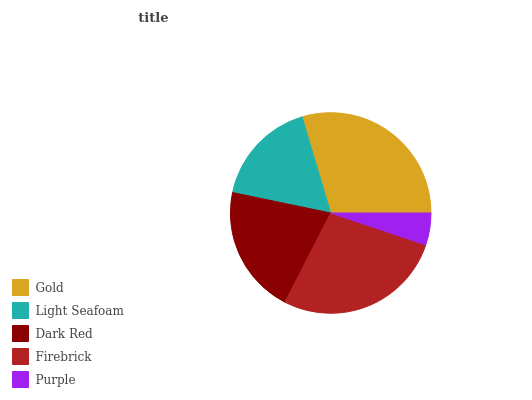Is Purple the minimum?
Answer yes or no. Yes. Is Gold the maximum?
Answer yes or no. Yes. Is Light Seafoam the minimum?
Answer yes or no. No. Is Light Seafoam the maximum?
Answer yes or no. No. Is Gold greater than Light Seafoam?
Answer yes or no. Yes. Is Light Seafoam less than Gold?
Answer yes or no. Yes. Is Light Seafoam greater than Gold?
Answer yes or no. No. Is Gold less than Light Seafoam?
Answer yes or no. No. Is Dark Red the high median?
Answer yes or no. Yes. Is Dark Red the low median?
Answer yes or no. Yes. Is Light Seafoam the high median?
Answer yes or no. No. Is Purple the low median?
Answer yes or no. No. 